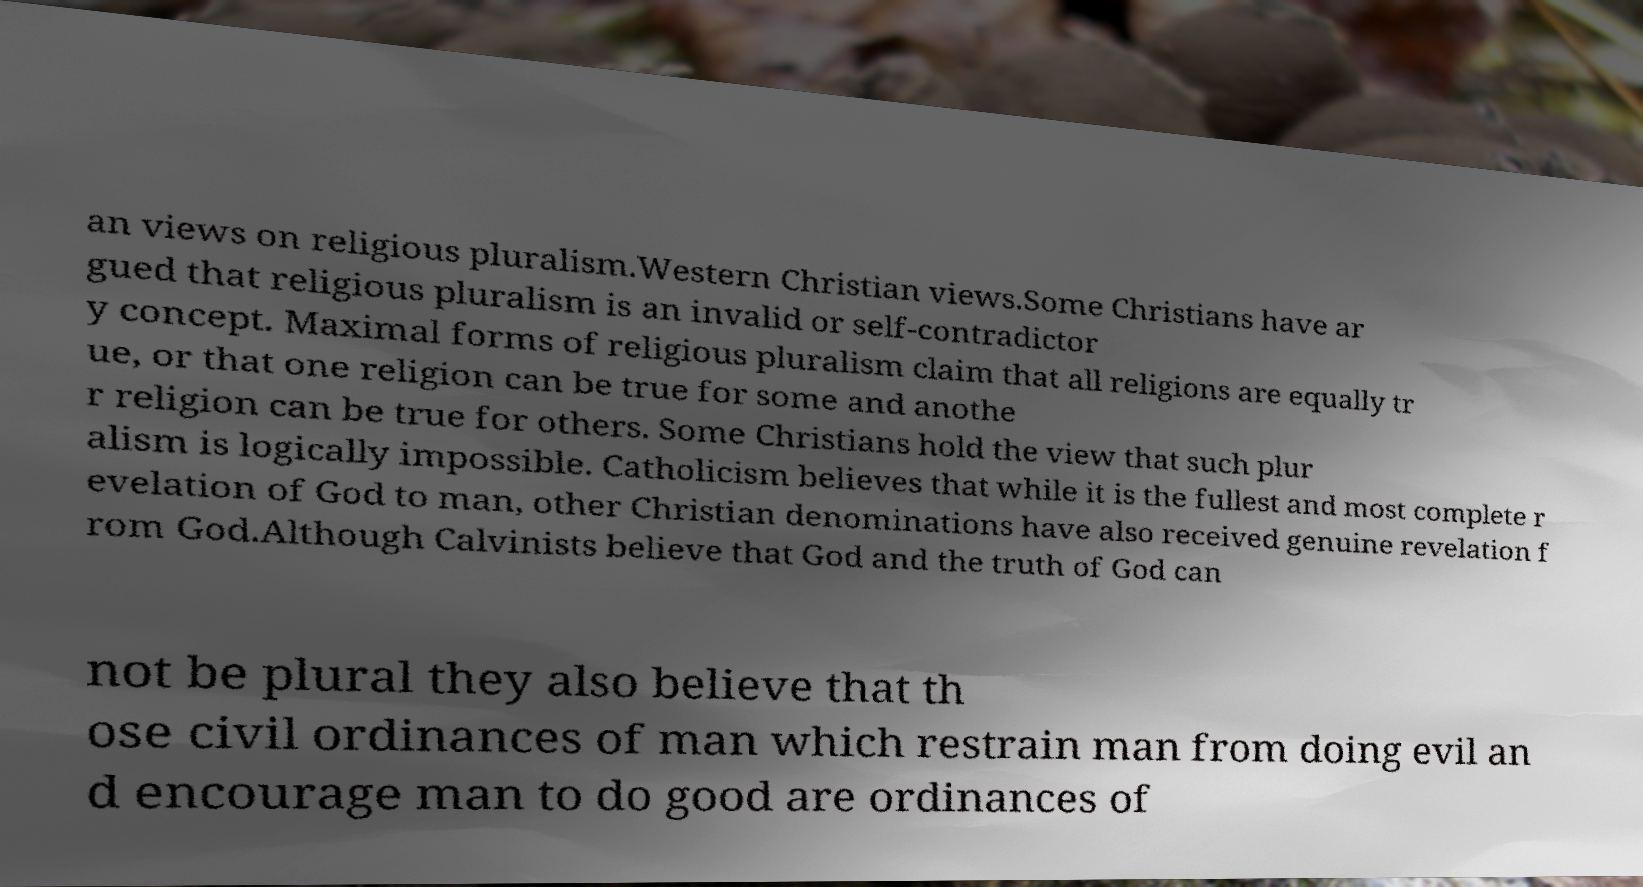Could you assist in decoding the text presented in this image and type it out clearly? an views on religious pluralism.Western Christian views.Some Christians have ar gued that religious pluralism is an invalid or self-contradictor y concept. Maximal forms of religious pluralism claim that all religions are equally tr ue, or that one religion can be true for some and anothe r religion can be true for others. Some Christians hold the view that such plur alism is logically impossible. Catholicism believes that while it is the fullest and most complete r evelation of God to man, other Christian denominations have also received genuine revelation f rom God.Although Calvinists believe that God and the truth of God can not be plural they also believe that th ose civil ordinances of man which restrain man from doing evil an d encourage man to do good are ordinances of 